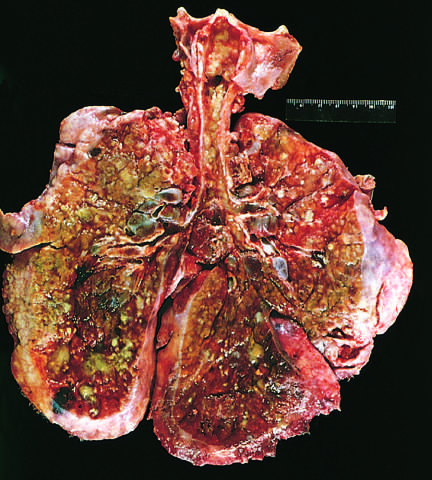s numerous friable mural thrombi consolidated by a combination of both secretions and pneumonia?
Answer the question using a single word or phrase. No 